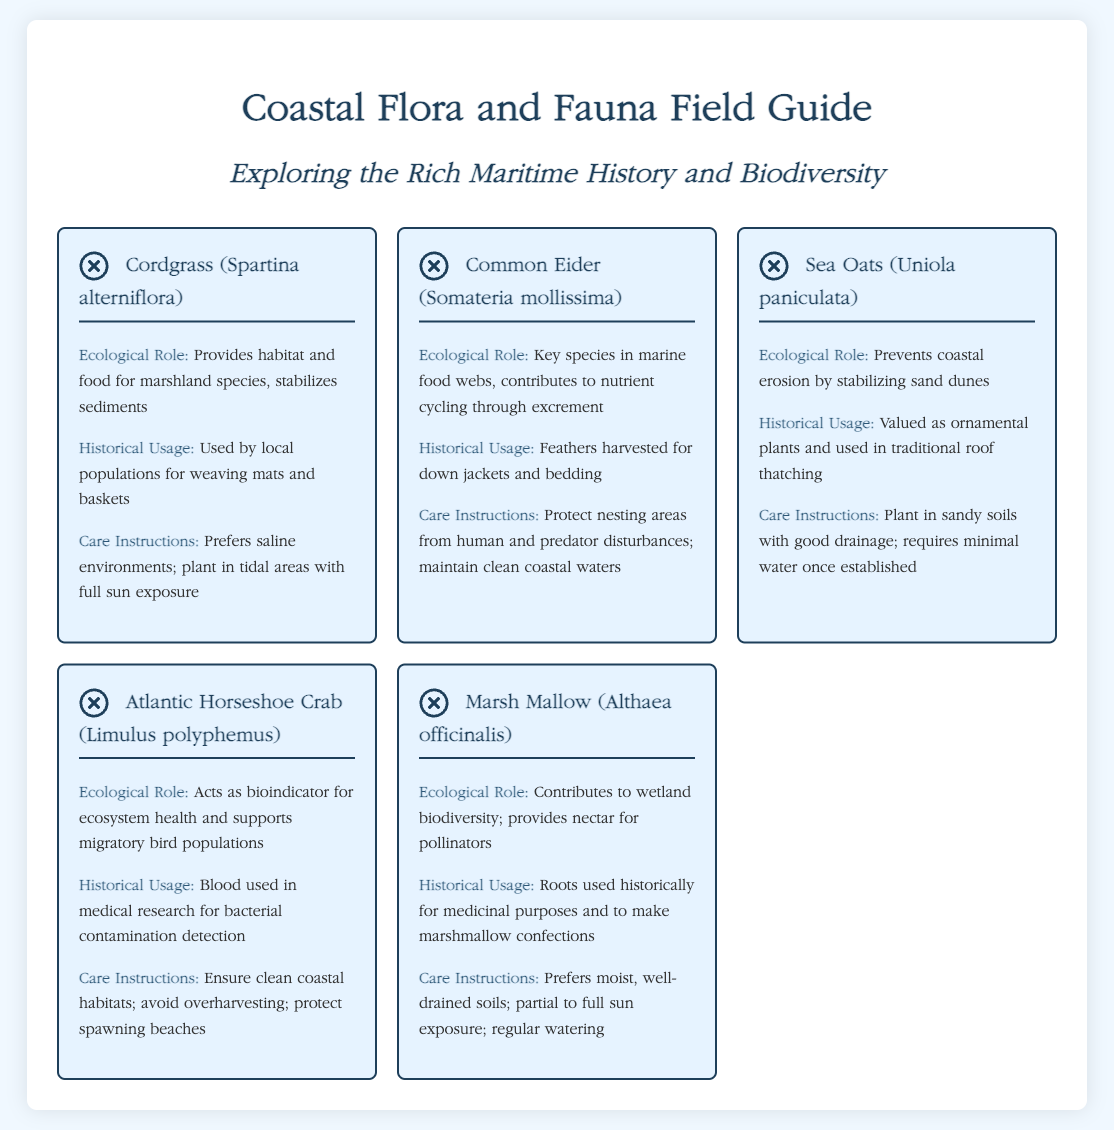What is the title of the document? The title of the document is specified in the <title> tag of the HTML code, which states "Coastal Flora and Fauna Field Guide".
Answer: Coastal Flora and Fauna Field Guide How many species are listed in the guide? The guide contains a total of six species cards presented in the species-grid section, each representing a different species.
Answer: 6 What is the ecological role of Cordgrass? The ecological role of Cordgrass is detailed in the species info section as providing habitat and food for marshland species and stabilizing sediments.
Answer: Provides habitat and food for marshland species, stabilizes sediments Which species' historical usage includes feathers harvested for down jackets? The historical usage of the Common Eider includes feathers harvested for down jackets and bedding, as mentioned in its section.
Answer: Common Eider What care instructions are provided for Sea Oats? The care instructions specified for Sea Oats in the document suggest planting in sandy soils with good drainage and requiring minimal water once established.
Answer: Plant in sandy soils with good drainage; requires minimal water once established Which species acts as a bioindicator for ecosystem health? The Atlantic Horseshoe Crab is identified as a bioindicator for ecosystem health, as outlined in its ecological role.
Answer: Atlantic Horseshoe Crab What type of document is this? The document is a product specification sheet that provides comprehensive details about various species, focusing on their ecological roles, historical usages, and care instructions.
Answer: Product specification sheet What is the primary focus of this field guide? The primary focus of the field guide is exploring the rich maritime history and biodiversity present in coastal areas, as indicated in the subtitle.
Answer: Exploring the rich maritime history and biodiversity 